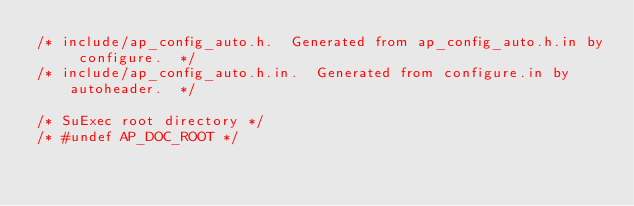<code> <loc_0><loc_0><loc_500><loc_500><_C_>/* include/ap_config_auto.h.  Generated from ap_config_auto.h.in by configure.  */
/* include/ap_config_auto.h.in.  Generated from configure.in by autoheader.  */

/* SuExec root directory */
/* #undef AP_DOC_ROOT */
</code> 